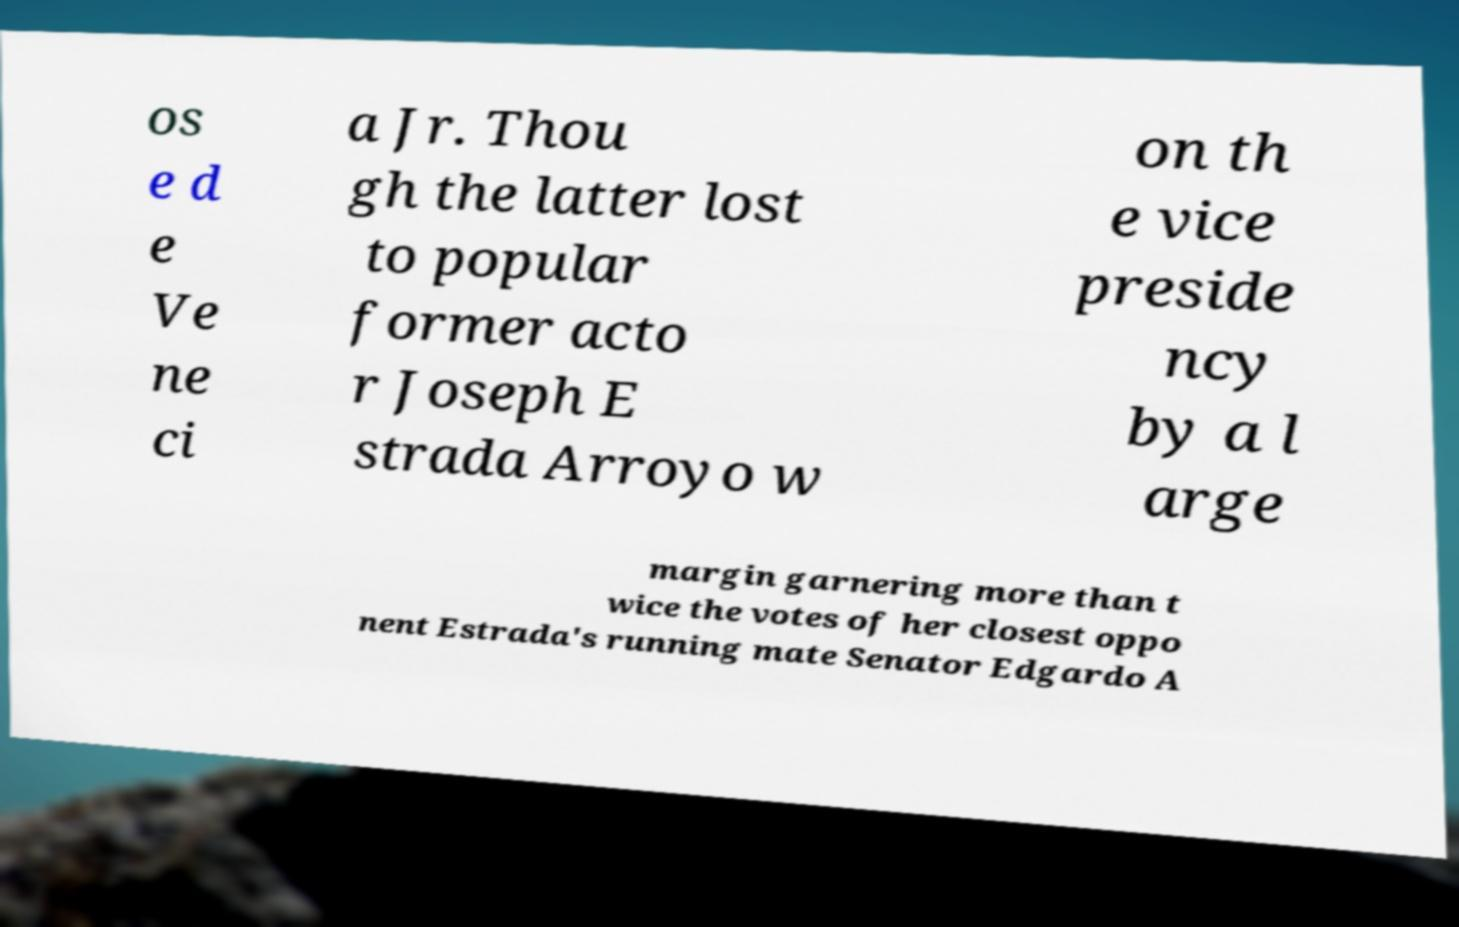Could you extract and type out the text from this image? os e d e Ve ne ci a Jr. Thou gh the latter lost to popular former acto r Joseph E strada Arroyo w on th e vice preside ncy by a l arge margin garnering more than t wice the votes of her closest oppo nent Estrada's running mate Senator Edgardo A 